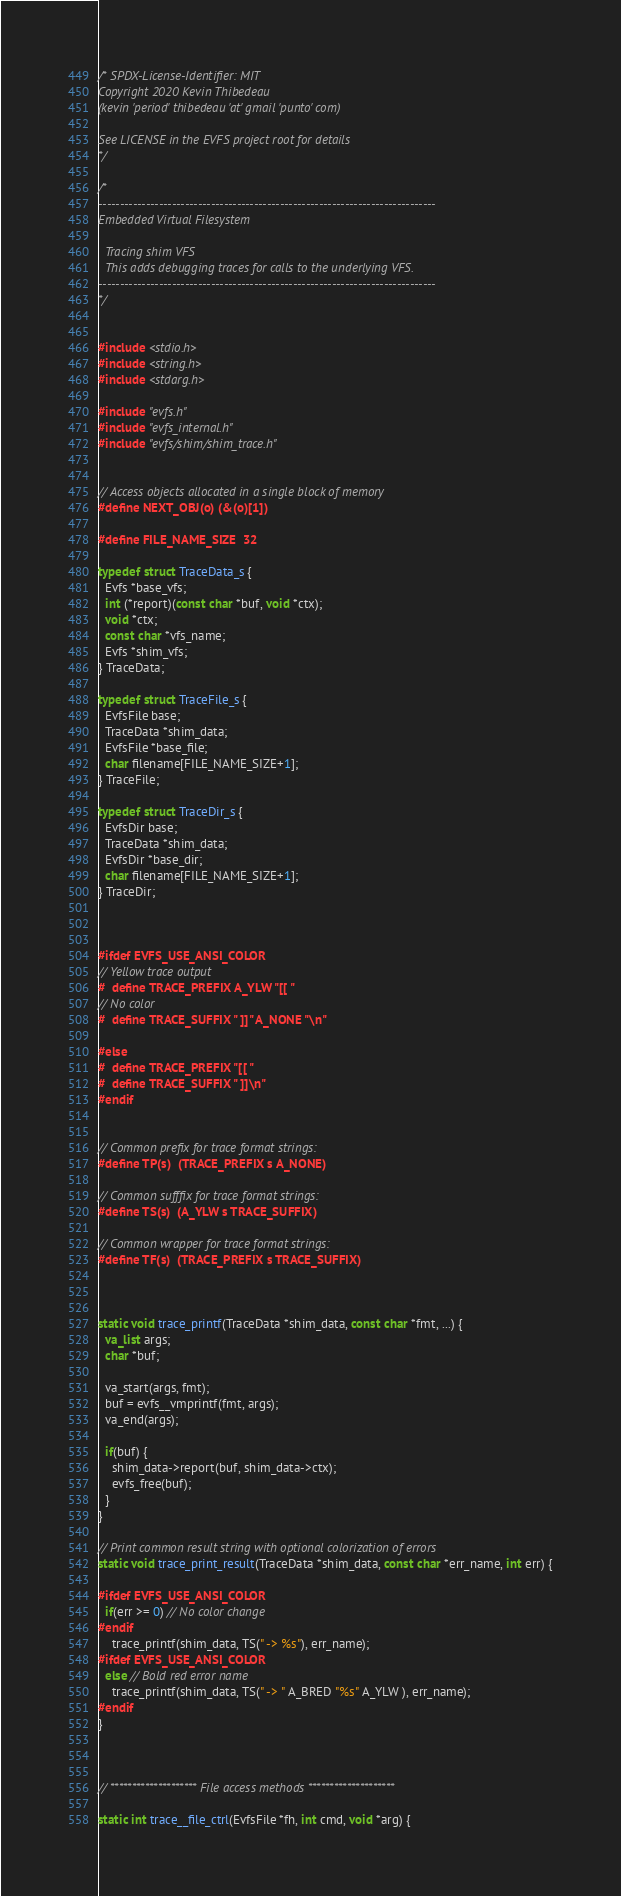<code> <loc_0><loc_0><loc_500><loc_500><_C_>/* SPDX-License-Identifier: MIT
Copyright 2020 Kevin Thibedeau
(kevin 'period' thibedeau 'at' gmail 'punto' com)

See LICENSE in the EVFS project root for details
*/

/*
------------------------------------------------------------------------------
Embedded Virtual Filesystem

  Tracing shim VFS
  This adds debugging traces for calls to the underlying VFS.
------------------------------------------------------------------------------
*/


#include <stdio.h>
#include <string.h>
#include <stdarg.h>

#include "evfs.h"
#include "evfs_internal.h"
#include "evfs/shim/shim_trace.h"


// Access objects allocated in a single block of memory
#define NEXT_OBJ(o) (&(o)[1])

#define FILE_NAME_SIZE  32

typedef struct TraceData_s {
  Evfs *base_vfs;
  int (*report)(const char *buf, void *ctx);
  void *ctx;
  const char *vfs_name;
  Evfs *shim_vfs;
} TraceData;

typedef struct TraceFile_s {
  EvfsFile base;
  TraceData *shim_data;
  EvfsFile *base_file;
  char filename[FILE_NAME_SIZE+1];
} TraceFile;

typedef struct TraceDir_s {
  EvfsDir base;
  TraceData *shim_data;
  EvfsDir *base_dir;
  char filename[FILE_NAME_SIZE+1];
} TraceDir;



#ifdef EVFS_USE_ANSI_COLOR
// Yellow trace output
#  define TRACE_PREFIX A_YLW "[[ "
// No color
#  define TRACE_SUFFIX " ]]" A_NONE "\n"

#else
#  define TRACE_PREFIX "[[ "
#  define TRACE_SUFFIX " ]]\n"
#endif


// Common prefix for trace format strings:
#define TP(s)  (TRACE_PREFIX s A_NONE)

// Common sufffix for trace format strings:
#define TS(s)  (A_YLW s TRACE_SUFFIX)

// Common wrapper for trace format strings:
#define TF(s)  (TRACE_PREFIX s TRACE_SUFFIX)



static void trace_printf(TraceData *shim_data, const char *fmt, ...) {
  va_list args;
  char *buf;

  va_start(args, fmt);
  buf = evfs__vmprintf(fmt, args);
  va_end(args);
  
  if(buf) {
    shim_data->report(buf, shim_data->ctx); 
    evfs_free(buf);
  }
}

// Print common result string with optional colorization of errors
static void trace_print_result(TraceData *shim_data, const char *err_name, int err) {

#ifdef EVFS_USE_ANSI_COLOR
  if(err >= 0) // No color change
#endif
    trace_printf(shim_data, TS(" -> %s"), err_name);
#ifdef EVFS_USE_ANSI_COLOR
  else // Bold red error name
    trace_printf(shim_data, TS(" -> " A_BRED "%s" A_YLW ), err_name);
#endif
}



// ******************** File access methods ********************

static int trace__file_ctrl(EvfsFile *fh, int cmd, void *arg) {</code> 